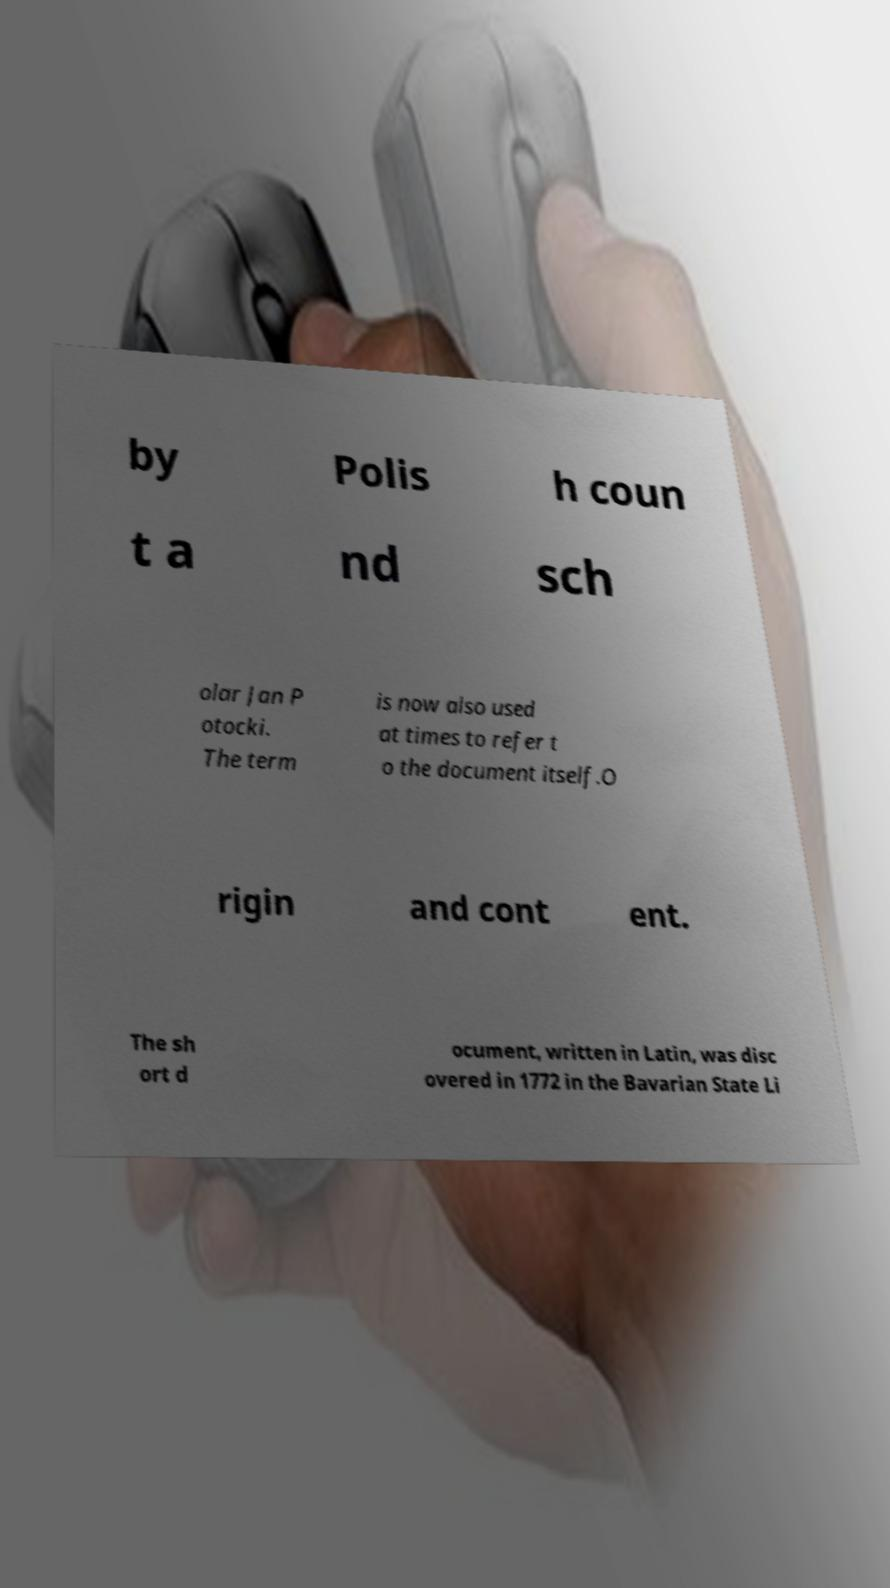For documentation purposes, I need the text within this image transcribed. Could you provide that? by Polis h coun t a nd sch olar Jan P otocki. The term is now also used at times to refer t o the document itself.O rigin and cont ent. The sh ort d ocument, written in Latin, was disc overed in 1772 in the Bavarian State Li 